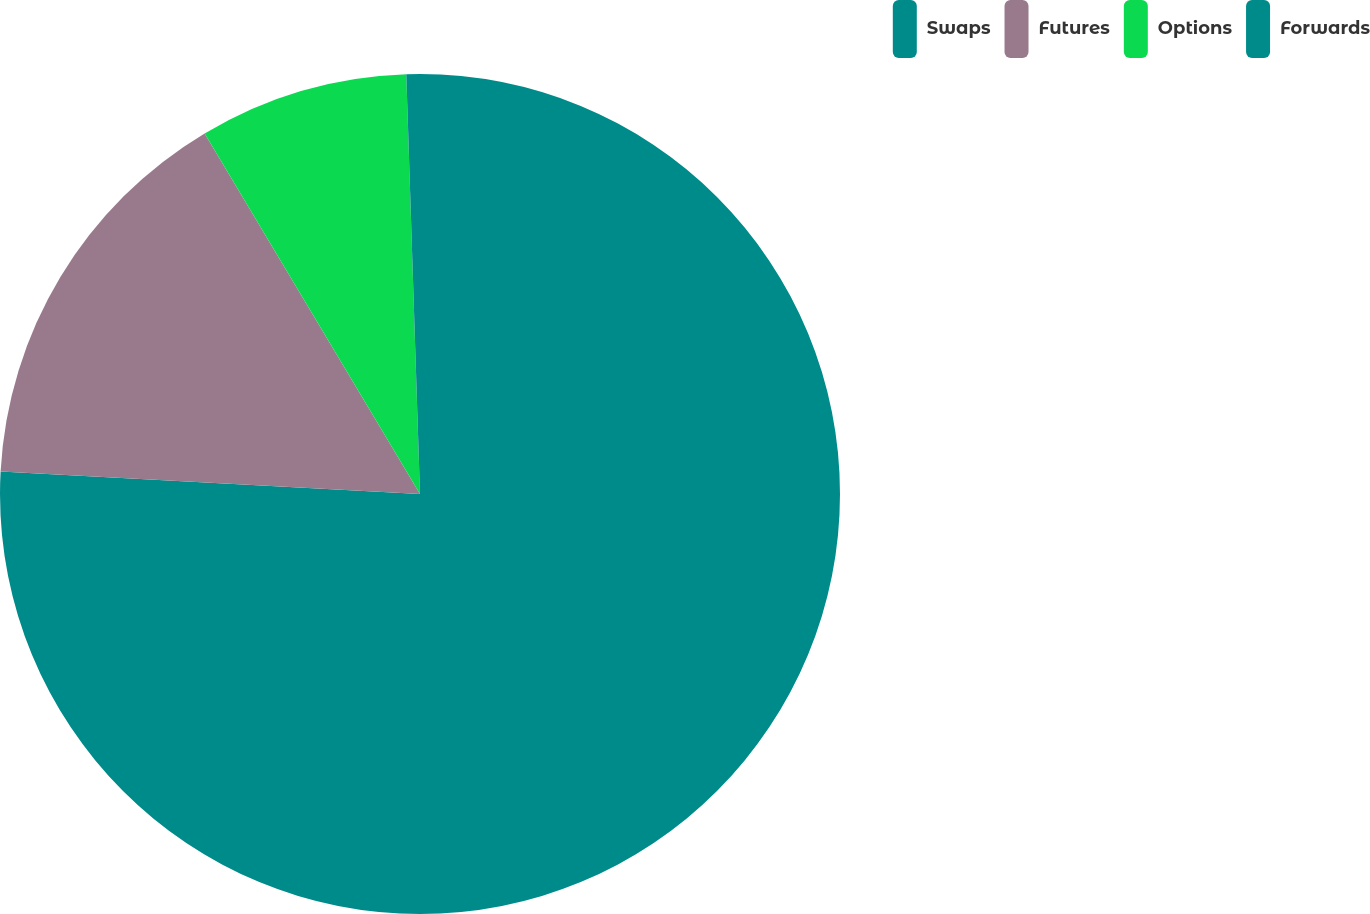<chart> <loc_0><loc_0><loc_500><loc_500><pie_chart><fcel>Swaps<fcel>Futures<fcel>Options<fcel>Forwards<nl><fcel>75.85%<fcel>15.58%<fcel>8.05%<fcel>0.52%<nl></chart> 